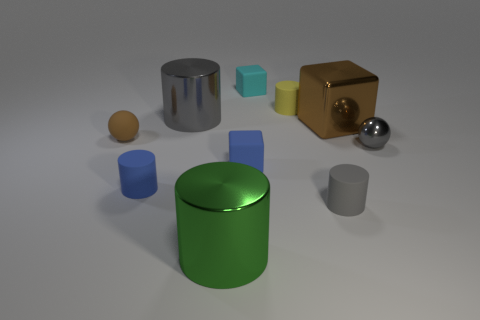Can you analyze the illumination in the image? Where might the light source be located? The illumination within the image suggests a light source positioned to the upper left, out of the frame, casting shadows that trail off toward the right. This is consistent with the highlights observed on the objects' left sides and their corresponding shadows on the opposite side. 